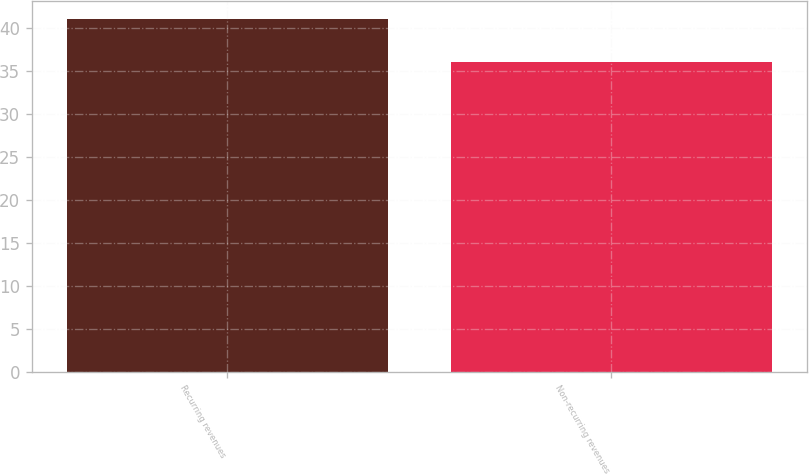Convert chart to OTSL. <chart><loc_0><loc_0><loc_500><loc_500><bar_chart><fcel>Recurring revenues<fcel>Non-recurring revenues<nl><fcel>41<fcel>36<nl></chart> 